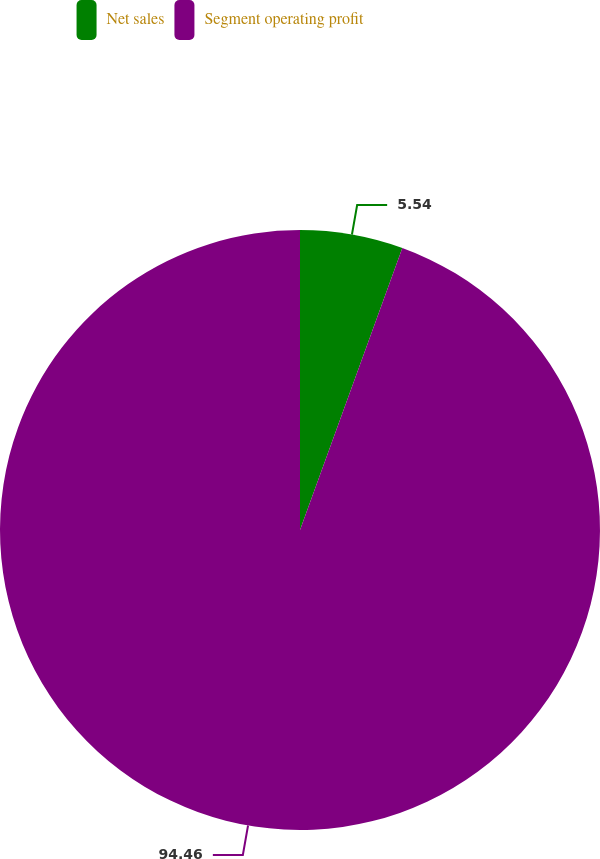Convert chart. <chart><loc_0><loc_0><loc_500><loc_500><pie_chart><fcel>Net sales<fcel>Segment operating profit<nl><fcel>5.54%<fcel>94.46%<nl></chart> 